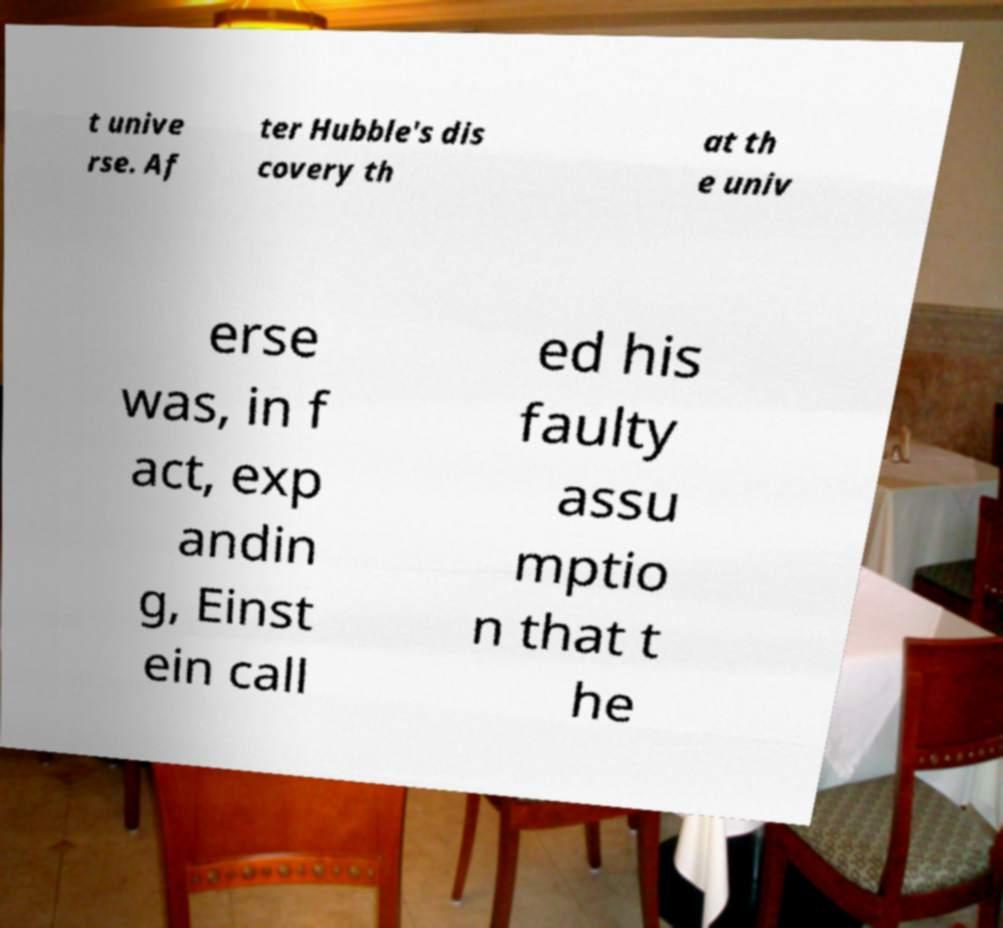Could you assist in decoding the text presented in this image and type it out clearly? t unive rse. Af ter Hubble's dis covery th at th e univ erse was, in f act, exp andin g, Einst ein call ed his faulty assu mptio n that t he 